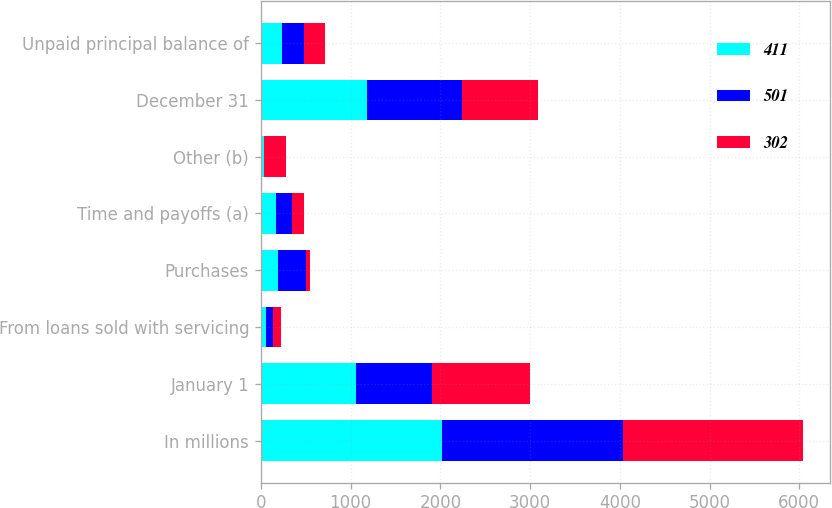Convert chart to OTSL. <chart><loc_0><loc_0><loc_500><loc_500><stacked_bar_chart><ecel><fcel>In millions<fcel>January 1<fcel>From loans sold with servicing<fcel>Purchases<fcel>Time and payoffs (a)<fcel>Other (b)<fcel>December 31<fcel>Unpaid principal balance of<nl><fcel>411<fcel>2016<fcel>1063<fcel>62<fcel>188<fcel>168<fcel>37<fcel>1182<fcel>238<nl><fcel>501<fcel>2015<fcel>845<fcel>78<fcel>316<fcel>178<fcel>2<fcel>1063<fcel>238<nl><fcel>302<fcel>2014<fcel>1087<fcel>85<fcel>45<fcel>134<fcel>238<fcel>845<fcel>238<nl></chart> 